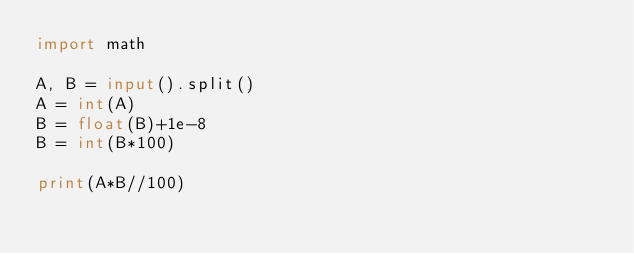Convert code to text. <code><loc_0><loc_0><loc_500><loc_500><_Python_>import math

A, B = input().split()
A = int(A)
B = float(B)+1e-8
B = int(B*100)

print(A*B//100)</code> 